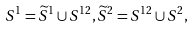Convert formula to latex. <formula><loc_0><loc_0><loc_500><loc_500>S ^ { 1 } = \widetilde { S } ^ { 1 } \cup S ^ { 1 2 } , \widetilde { S } ^ { 2 } = S ^ { 1 2 } \cup S ^ { 2 } ,</formula> 